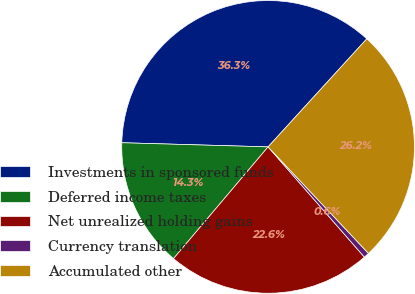Convert chart. <chart><loc_0><loc_0><loc_500><loc_500><pie_chart><fcel>Investments in sponsored funds<fcel>Deferred income taxes<fcel>Net unrealized holding gains<fcel>Currency translation<fcel>Accumulated other<nl><fcel>36.33%<fcel>14.27%<fcel>22.61%<fcel>0.6%<fcel>26.19%<nl></chart> 